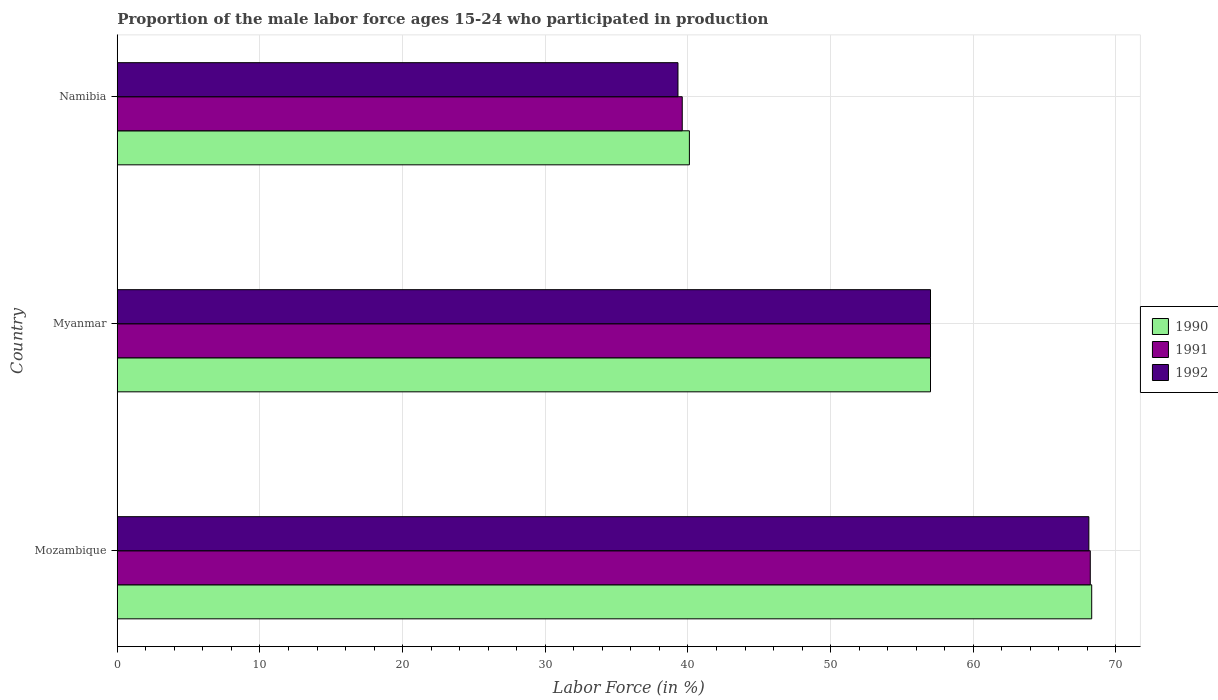How many groups of bars are there?
Keep it short and to the point. 3. Are the number of bars on each tick of the Y-axis equal?
Offer a very short reply. Yes. How many bars are there on the 3rd tick from the top?
Ensure brevity in your answer.  3. How many bars are there on the 2nd tick from the bottom?
Your answer should be very brief. 3. What is the label of the 2nd group of bars from the top?
Your response must be concise. Myanmar. In how many cases, is the number of bars for a given country not equal to the number of legend labels?
Offer a very short reply. 0. What is the proportion of the male labor force who participated in production in 1992 in Myanmar?
Offer a terse response. 57. Across all countries, what is the maximum proportion of the male labor force who participated in production in 1990?
Your answer should be very brief. 68.3. Across all countries, what is the minimum proportion of the male labor force who participated in production in 1992?
Your response must be concise. 39.3. In which country was the proportion of the male labor force who participated in production in 1991 maximum?
Give a very brief answer. Mozambique. In which country was the proportion of the male labor force who participated in production in 1990 minimum?
Offer a very short reply. Namibia. What is the total proportion of the male labor force who participated in production in 1990 in the graph?
Make the answer very short. 165.4. What is the difference between the proportion of the male labor force who participated in production in 1990 in Myanmar and that in Namibia?
Provide a succinct answer. 16.9. What is the difference between the proportion of the male labor force who participated in production in 1991 in Namibia and the proportion of the male labor force who participated in production in 1990 in Mozambique?
Provide a succinct answer. -28.7. What is the average proportion of the male labor force who participated in production in 1991 per country?
Keep it short and to the point. 54.93. What is the difference between the proportion of the male labor force who participated in production in 1990 and proportion of the male labor force who participated in production in 1992 in Namibia?
Give a very brief answer. 0.8. What is the ratio of the proportion of the male labor force who participated in production in 1991 in Mozambique to that in Myanmar?
Make the answer very short. 1.2. Is the proportion of the male labor force who participated in production in 1990 in Myanmar less than that in Namibia?
Keep it short and to the point. No. Is the difference between the proportion of the male labor force who participated in production in 1990 in Myanmar and Namibia greater than the difference between the proportion of the male labor force who participated in production in 1992 in Myanmar and Namibia?
Offer a very short reply. No. What is the difference between the highest and the second highest proportion of the male labor force who participated in production in 1990?
Offer a very short reply. 11.3. What is the difference between the highest and the lowest proportion of the male labor force who participated in production in 1990?
Give a very brief answer. 28.2. In how many countries, is the proportion of the male labor force who participated in production in 1991 greater than the average proportion of the male labor force who participated in production in 1991 taken over all countries?
Offer a terse response. 2. What does the 2nd bar from the top in Mozambique represents?
Your response must be concise. 1991. Is it the case that in every country, the sum of the proportion of the male labor force who participated in production in 1991 and proportion of the male labor force who participated in production in 1992 is greater than the proportion of the male labor force who participated in production in 1990?
Provide a short and direct response. Yes. Are the values on the major ticks of X-axis written in scientific E-notation?
Provide a succinct answer. No. Where does the legend appear in the graph?
Your answer should be compact. Center right. How are the legend labels stacked?
Provide a short and direct response. Vertical. What is the title of the graph?
Give a very brief answer. Proportion of the male labor force ages 15-24 who participated in production. Does "1978" appear as one of the legend labels in the graph?
Provide a short and direct response. No. What is the label or title of the Y-axis?
Your answer should be very brief. Country. What is the Labor Force (in %) of 1990 in Mozambique?
Provide a short and direct response. 68.3. What is the Labor Force (in %) in 1991 in Mozambique?
Ensure brevity in your answer.  68.2. What is the Labor Force (in %) of 1992 in Mozambique?
Provide a succinct answer. 68.1. What is the Labor Force (in %) of 1990 in Myanmar?
Offer a very short reply. 57. What is the Labor Force (in %) of 1992 in Myanmar?
Give a very brief answer. 57. What is the Labor Force (in %) in 1990 in Namibia?
Your answer should be very brief. 40.1. What is the Labor Force (in %) of 1991 in Namibia?
Your answer should be very brief. 39.6. What is the Labor Force (in %) in 1992 in Namibia?
Your response must be concise. 39.3. Across all countries, what is the maximum Labor Force (in %) of 1990?
Make the answer very short. 68.3. Across all countries, what is the maximum Labor Force (in %) in 1991?
Your answer should be very brief. 68.2. Across all countries, what is the maximum Labor Force (in %) of 1992?
Offer a terse response. 68.1. Across all countries, what is the minimum Labor Force (in %) of 1990?
Make the answer very short. 40.1. Across all countries, what is the minimum Labor Force (in %) in 1991?
Your answer should be very brief. 39.6. Across all countries, what is the minimum Labor Force (in %) in 1992?
Provide a short and direct response. 39.3. What is the total Labor Force (in %) in 1990 in the graph?
Ensure brevity in your answer.  165.4. What is the total Labor Force (in %) of 1991 in the graph?
Give a very brief answer. 164.8. What is the total Labor Force (in %) in 1992 in the graph?
Offer a very short reply. 164.4. What is the difference between the Labor Force (in %) of 1992 in Mozambique and that in Myanmar?
Your answer should be very brief. 11.1. What is the difference between the Labor Force (in %) in 1990 in Mozambique and that in Namibia?
Make the answer very short. 28.2. What is the difference between the Labor Force (in %) of 1991 in Mozambique and that in Namibia?
Your answer should be compact. 28.6. What is the difference between the Labor Force (in %) of 1992 in Mozambique and that in Namibia?
Your response must be concise. 28.8. What is the difference between the Labor Force (in %) in 1991 in Myanmar and that in Namibia?
Provide a short and direct response. 17.4. What is the difference between the Labor Force (in %) in 1990 in Mozambique and the Labor Force (in %) in 1991 in Myanmar?
Provide a short and direct response. 11.3. What is the difference between the Labor Force (in %) of 1990 in Mozambique and the Labor Force (in %) of 1992 in Myanmar?
Make the answer very short. 11.3. What is the difference between the Labor Force (in %) of 1990 in Mozambique and the Labor Force (in %) of 1991 in Namibia?
Ensure brevity in your answer.  28.7. What is the difference between the Labor Force (in %) in 1990 in Mozambique and the Labor Force (in %) in 1992 in Namibia?
Offer a terse response. 29. What is the difference between the Labor Force (in %) of 1991 in Mozambique and the Labor Force (in %) of 1992 in Namibia?
Provide a short and direct response. 28.9. What is the difference between the Labor Force (in %) in 1990 in Myanmar and the Labor Force (in %) in 1991 in Namibia?
Offer a very short reply. 17.4. What is the difference between the Labor Force (in %) in 1991 in Myanmar and the Labor Force (in %) in 1992 in Namibia?
Offer a very short reply. 17.7. What is the average Labor Force (in %) in 1990 per country?
Offer a very short reply. 55.13. What is the average Labor Force (in %) in 1991 per country?
Offer a terse response. 54.93. What is the average Labor Force (in %) in 1992 per country?
Provide a short and direct response. 54.8. What is the difference between the Labor Force (in %) in 1990 and Labor Force (in %) in 1991 in Mozambique?
Offer a terse response. 0.1. What is the difference between the Labor Force (in %) in 1990 and Labor Force (in %) in 1992 in Mozambique?
Your response must be concise. 0.2. What is the difference between the Labor Force (in %) in 1991 and Labor Force (in %) in 1992 in Mozambique?
Provide a short and direct response. 0.1. What is the difference between the Labor Force (in %) of 1990 and Labor Force (in %) of 1991 in Myanmar?
Give a very brief answer. 0. What is the difference between the Labor Force (in %) of 1990 and Labor Force (in %) of 1992 in Namibia?
Your response must be concise. 0.8. What is the difference between the Labor Force (in %) of 1991 and Labor Force (in %) of 1992 in Namibia?
Offer a terse response. 0.3. What is the ratio of the Labor Force (in %) in 1990 in Mozambique to that in Myanmar?
Provide a short and direct response. 1.2. What is the ratio of the Labor Force (in %) in 1991 in Mozambique to that in Myanmar?
Your response must be concise. 1.2. What is the ratio of the Labor Force (in %) of 1992 in Mozambique to that in Myanmar?
Make the answer very short. 1.19. What is the ratio of the Labor Force (in %) of 1990 in Mozambique to that in Namibia?
Offer a very short reply. 1.7. What is the ratio of the Labor Force (in %) in 1991 in Mozambique to that in Namibia?
Give a very brief answer. 1.72. What is the ratio of the Labor Force (in %) of 1992 in Mozambique to that in Namibia?
Ensure brevity in your answer.  1.73. What is the ratio of the Labor Force (in %) in 1990 in Myanmar to that in Namibia?
Offer a very short reply. 1.42. What is the ratio of the Labor Force (in %) of 1991 in Myanmar to that in Namibia?
Keep it short and to the point. 1.44. What is the ratio of the Labor Force (in %) in 1992 in Myanmar to that in Namibia?
Keep it short and to the point. 1.45. What is the difference between the highest and the second highest Labor Force (in %) of 1992?
Provide a short and direct response. 11.1. What is the difference between the highest and the lowest Labor Force (in %) of 1990?
Ensure brevity in your answer.  28.2. What is the difference between the highest and the lowest Labor Force (in %) in 1991?
Ensure brevity in your answer.  28.6. What is the difference between the highest and the lowest Labor Force (in %) in 1992?
Provide a succinct answer. 28.8. 